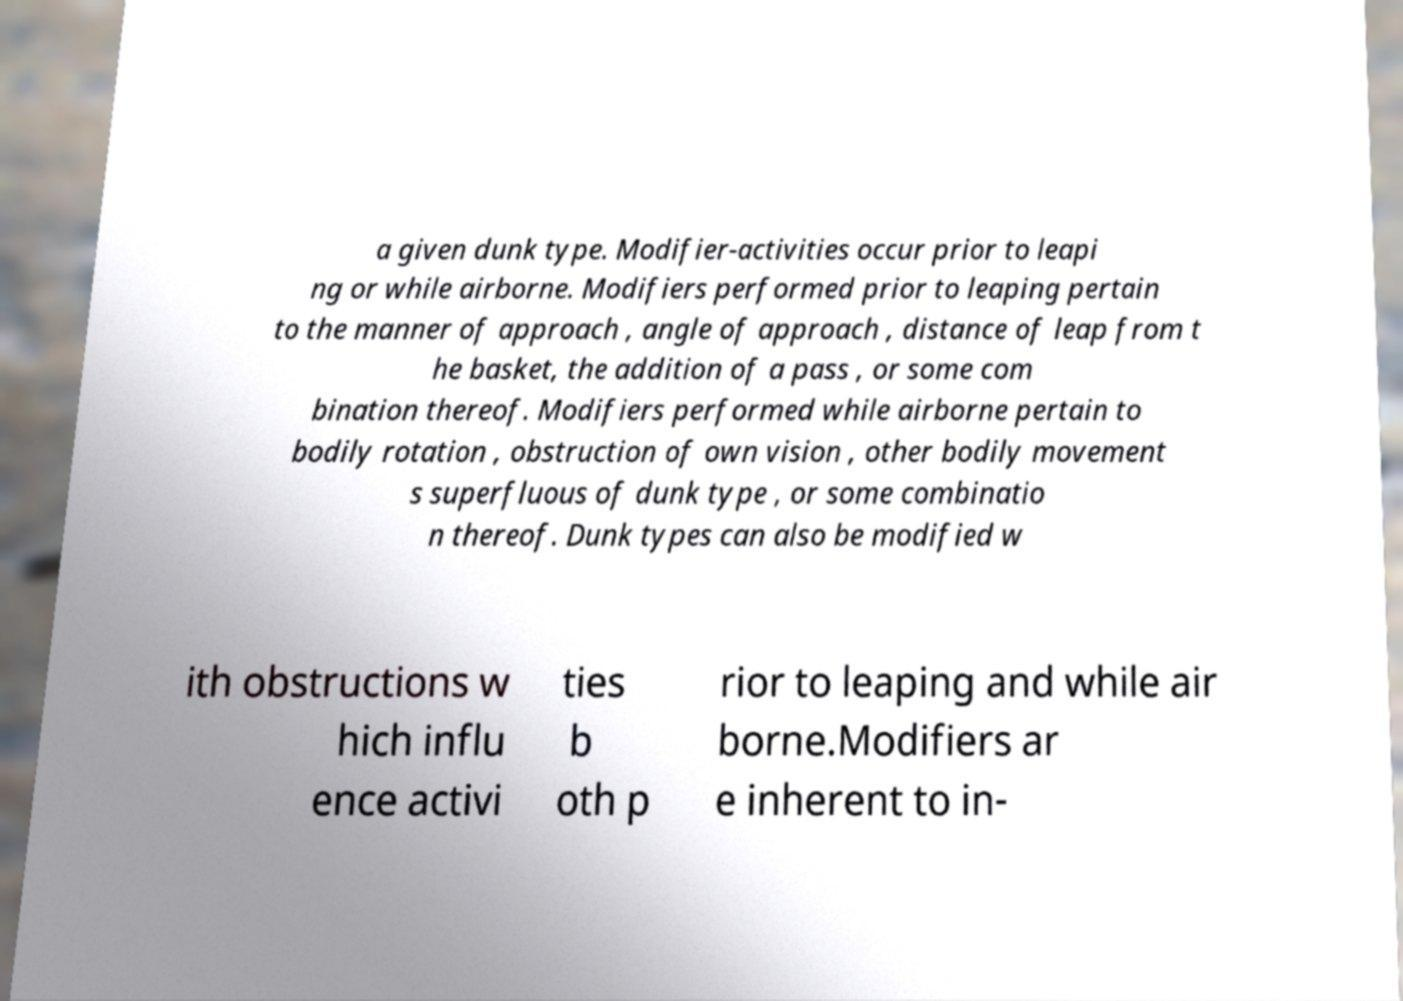Please identify and transcribe the text found in this image. a given dunk type. Modifier-activities occur prior to leapi ng or while airborne. Modifiers performed prior to leaping pertain to the manner of approach , angle of approach , distance of leap from t he basket, the addition of a pass , or some com bination thereof. Modifiers performed while airborne pertain to bodily rotation , obstruction of own vision , other bodily movement s superfluous of dunk type , or some combinatio n thereof. Dunk types can also be modified w ith obstructions w hich influ ence activi ties b oth p rior to leaping and while air borne.Modifiers ar e inherent to in- 